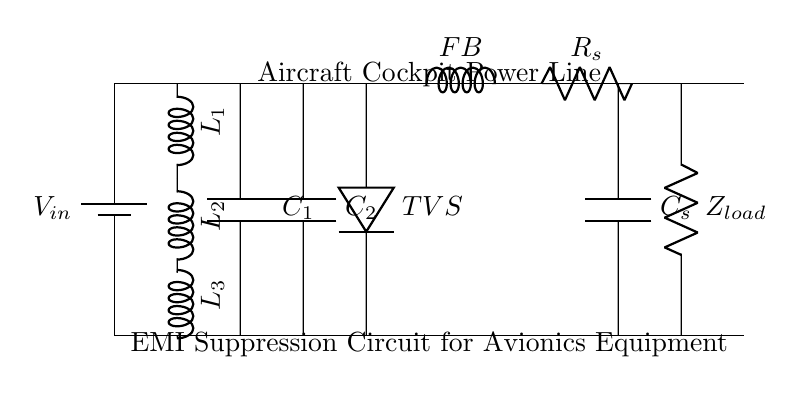What type of circuit is this? The circuit is an EMI suppression circuit designed for avionics equipment. This can be inferred from the labeled components and the overall purpose of reducing electromagnetic interference, crucial for sensitive electronic systems in aircraft.
Answer: EMI suppression circuit What is the purpose of the inductor labeled L1? Inductor L1, as part of the EMI filter, is used to impede high-frequency noise while allowing low-frequency signals to pass through, thus reducing electromagnetic interference. Its position at the top of the circuit supports this function.
Answer: Reduce EMI How many capacitors are present in this circuit? The circuit contains two capacitors, labeled C1 and C2, which can be identified in the section that connects vertically from the main power line to ground.
Answer: Two What is indicated by the component labeled TVS? The component labeled TVS is a Transient Voltage Suppressor, which is used to protect sensitive avionics equipment from voltage spikes. Its position in the circuit reflects its role in safeguarding components against transient events.
Answer: Voltage protection What is the significance of the ferrite bead (labeled FB) in this circuit? The ferrite bead, FB, serves to suppress high-frequency noise and prevent it from reaching the load. It is crucial in maintaining the signal integrity by reducing EMI while allowing DC signals to pass. Its position indicates it's part of the EMI filtering.
Answer: High-frequency noise suppression What does the RC snubber circuit (Rs and Cs) accomplish? The RC snubber circuit helps manage voltage spikes and reduce ringing in the circuit when switching operations occur. It consists of a resistor (Rs) and capacitor (Cs), working together to dampen fluctuations in voltage and current.
Answer: Voltage spike management What is the load represented by Zload? The load represented by Zload is the final component in this circuit diagram, showing the resistance or impedance that the EMI suppression circuit is supplying power to. This load is a critical part of determining the performance and behavior of the circuit under operational conditions.
Answer: Load impedance 